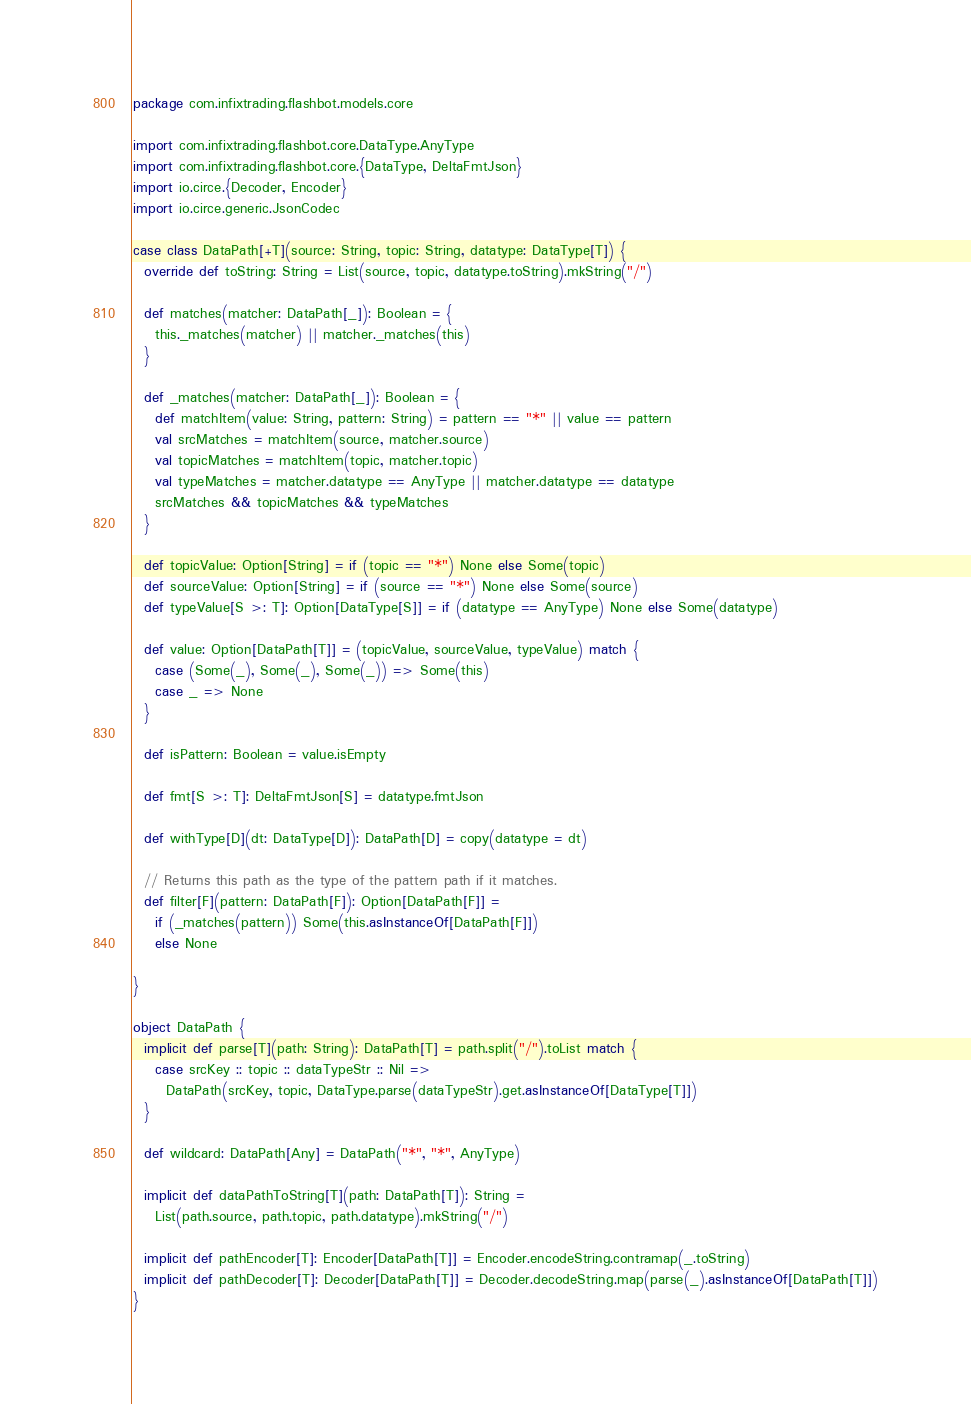<code> <loc_0><loc_0><loc_500><loc_500><_Scala_>package com.infixtrading.flashbot.models.core

import com.infixtrading.flashbot.core.DataType.AnyType
import com.infixtrading.flashbot.core.{DataType, DeltaFmtJson}
import io.circe.{Decoder, Encoder}
import io.circe.generic.JsonCodec

case class DataPath[+T](source: String, topic: String, datatype: DataType[T]) {
  override def toString: String = List(source, topic, datatype.toString).mkString("/")

  def matches(matcher: DataPath[_]): Boolean = {
    this._matches(matcher) || matcher._matches(this)
  }

  def _matches(matcher: DataPath[_]): Boolean = {
    def matchItem(value: String, pattern: String) = pattern == "*" || value == pattern
    val srcMatches = matchItem(source, matcher.source)
    val topicMatches = matchItem(topic, matcher.topic)
    val typeMatches = matcher.datatype == AnyType || matcher.datatype == datatype
    srcMatches && topicMatches && typeMatches
  }

  def topicValue: Option[String] = if (topic == "*") None else Some(topic)
  def sourceValue: Option[String] = if (source == "*") None else Some(source)
  def typeValue[S >: T]: Option[DataType[S]] = if (datatype == AnyType) None else Some(datatype)

  def value: Option[DataPath[T]] = (topicValue, sourceValue, typeValue) match {
    case (Some(_), Some(_), Some(_)) => Some(this)
    case _ => None
  }

  def isPattern: Boolean = value.isEmpty

  def fmt[S >: T]: DeltaFmtJson[S] = datatype.fmtJson

  def withType[D](dt: DataType[D]): DataPath[D] = copy(datatype = dt)

  // Returns this path as the type of the pattern path if it matches.
  def filter[F](pattern: DataPath[F]): Option[DataPath[F]] =
    if (_matches(pattern)) Some(this.asInstanceOf[DataPath[F]])
    else None

}

object DataPath {
  implicit def parse[T](path: String): DataPath[T] = path.split("/").toList match {
    case srcKey :: topic :: dataTypeStr :: Nil =>
      DataPath(srcKey, topic, DataType.parse(dataTypeStr).get.asInstanceOf[DataType[T]])
  }

  def wildcard: DataPath[Any] = DataPath("*", "*", AnyType)

  implicit def dataPathToString[T](path: DataPath[T]): String =
    List(path.source, path.topic, path.datatype).mkString("/")

  implicit def pathEncoder[T]: Encoder[DataPath[T]] = Encoder.encodeString.contramap(_.toString)
  implicit def pathDecoder[T]: Decoder[DataPath[T]] = Decoder.decodeString.map(parse(_).asInstanceOf[DataPath[T]])
}
</code> 